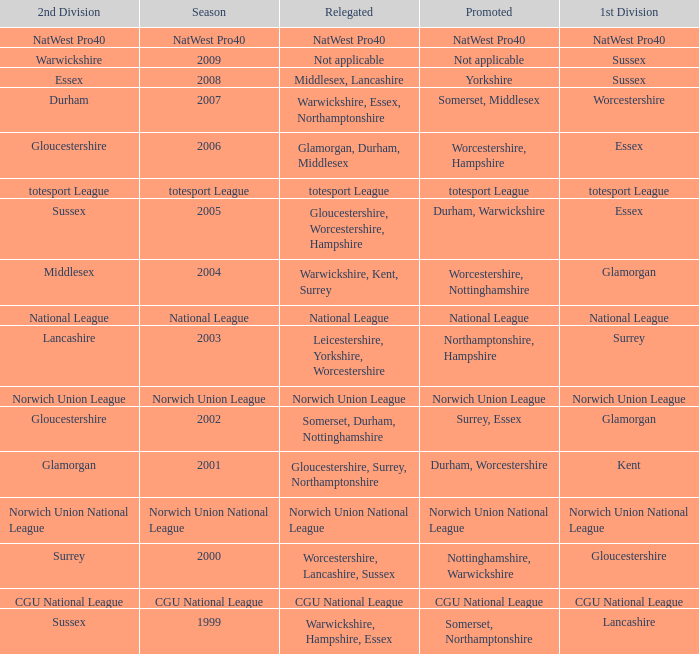What season was Norwich Union League promoted? Norwich Union League. 